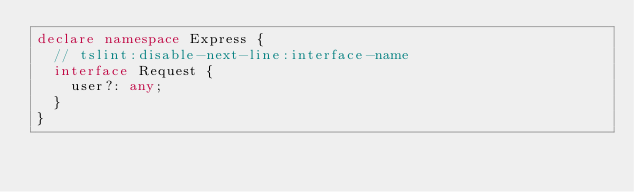Convert code to text. <code><loc_0><loc_0><loc_500><loc_500><_TypeScript_>declare namespace Express {
  // tslint:disable-next-line:interface-name
  interface Request {
    user?: any;
  }
}
</code> 